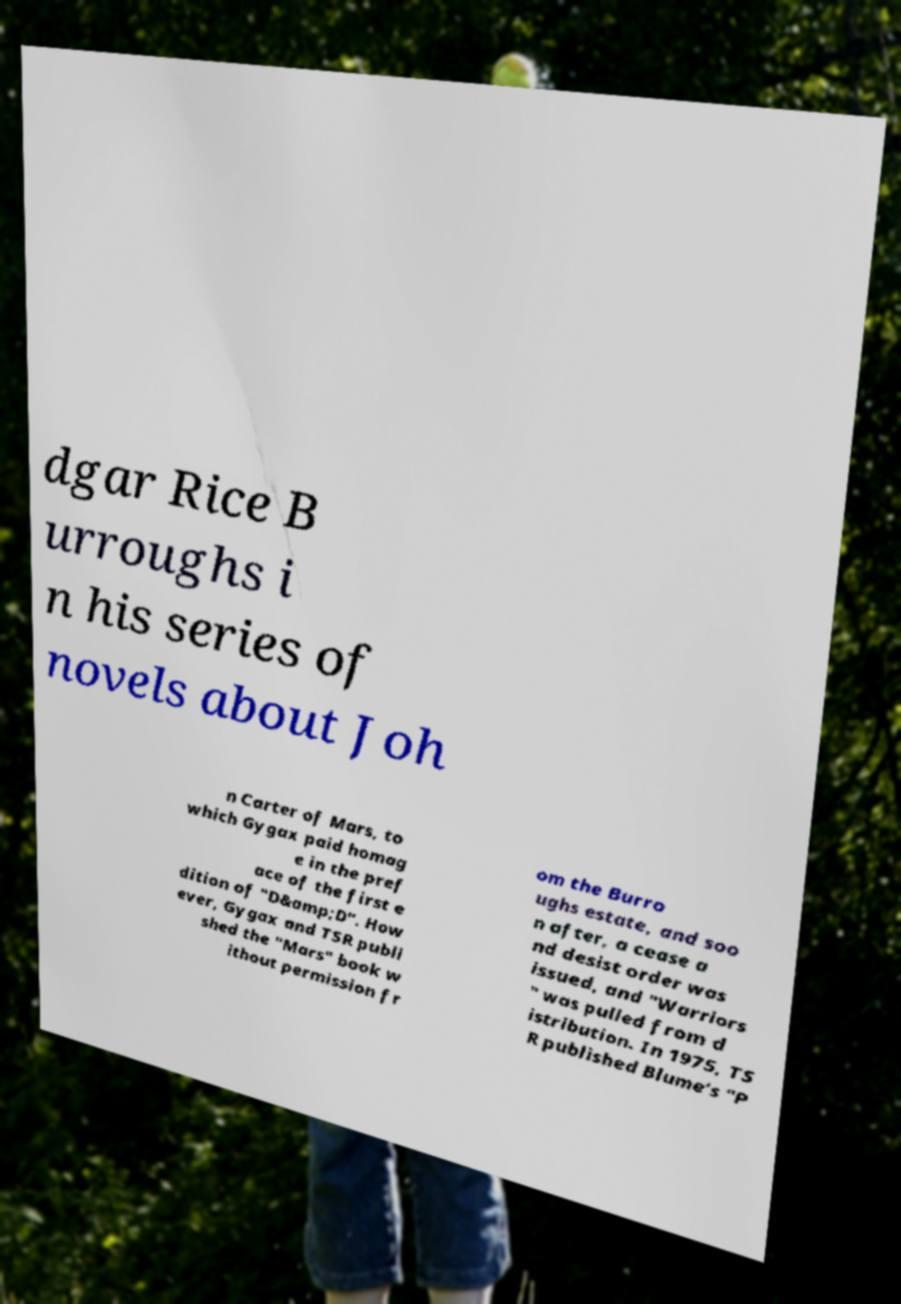Could you assist in decoding the text presented in this image and type it out clearly? dgar Rice B urroughs i n his series of novels about Joh n Carter of Mars, to which Gygax paid homag e in the pref ace of the first e dition of "D&amp;D". How ever, Gygax and TSR publi shed the "Mars" book w ithout permission fr om the Burro ughs estate, and soo n after, a cease a nd desist order was issued, and "Warriors " was pulled from d istribution. In 1975, TS R published Blume's "P 